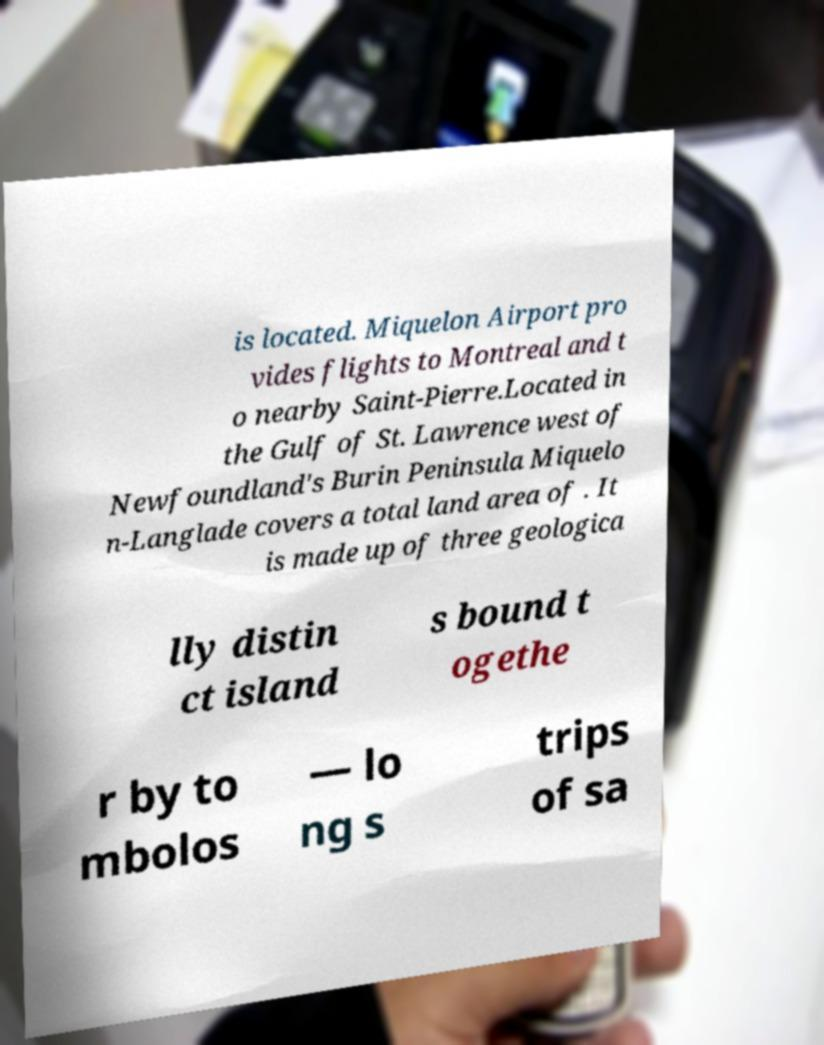Please identify and transcribe the text found in this image. is located. Miquelon Airport pro vides flights to Montreal and t o nearby Saint-Pierre.Located in the Gulf of St. Lawrence west of Newfoundland's Burin Peninsula Miquelo n-Langlade covers a total land area of . It is made up of three geologica lly distin ct island s bound t ogethe r by to mbolos — lo ng s trips of sa 